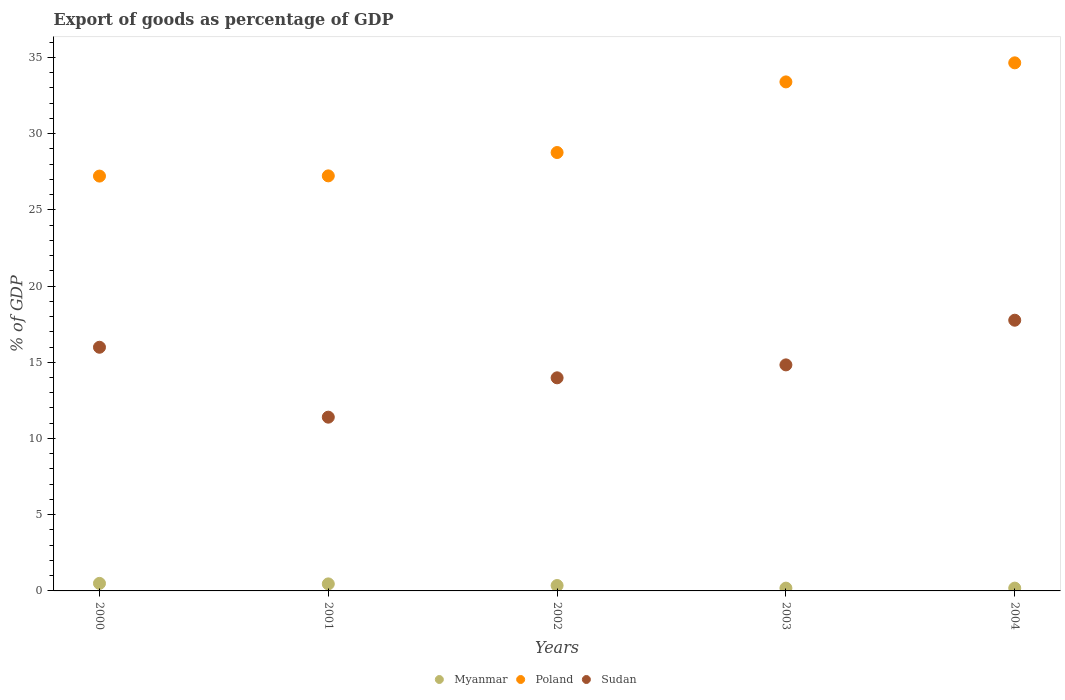How many different coloured dotlines are there?
Provide a succinct answer. 3. Is the number of dotlines equal to the number of legend labels?
Keep it short and to the point. Yes. What is the export of goods as percentage of GDP in Sudan in 2004?
Ensure brevity in your answer.  17.76. Across all years, what is the maximum export of goods as percentage of GDP in Sudan?
Give a very brief answer. 17.76. Across all years, what is the minimum export of goods as percentage of GDP in Myanmar?
Ensure brevity in your answer.  0.18. In which year was the export of goods as percentage of GDP in Sudan maximum?
Make the answer very short. 2004. What is the total export of goods as percentage of GDP in Poland in the graph?
Offer a terse response. 151.23. What is the difference between the export of goods as percentage of GDP in Poland in 2000 and that in 2004?
Offer a very short reply. -7.43. What is the difference between the export of goods as percentage of GDP in Sudan in 2004 and the export of goods as percentage of GDP in Poland in 2000?
Provide a short and direct response. -9.45. What is the average export of goods as percentage of GDP in Myanmar per year?
Keep it short and to the point. 0.34. In the year 2003, what is the difference between the export of goods as percentage of GDP in Sudan and export of goods as percentage of GDP in Myanmar?
Your answer should be compact. 14.64. What is the ratio of the export of goods as percentage of GDP in Poland in 2001 to that in 2004?
Ensure brevity in your answer.  0.79. Is the difference between the export of goods as percentage of GDP in Sudan in 2003 and 2004 greater than the difference between the export of goods as percentage of GDP in Myanmar in 2003 and 2004?
Provide a short and direct response. No. What is the difference between the highest and the second highest export of goods as percentage of GDP in Poland?
Your answer should be very brief. 1.25. What is the difference between the highest and the lowest export of goods as percentage of GDP in Poland?
Offer a very short reply. 7.43. Does the export of goods as percentage of GDP in Poland monotonically increase over the years?
Keep it short and to the point. Yes. Is the export of goods as percentage of GDP in Poland strictly less than the export of goods as percentage of GDP in Sudan over the years?
Keep it short and to the point. No. How many dotlines are there?
Keep it short and to the point. 3. How many years are there in the graph?
Provide a short and direct response. 5. Are the values on the major ticks of Y-axis written in scientific E-notation?
Ensure brevity in your answer.  No. Where does the legend appear in the graph?
Offer a very short reply. Bottom center. How are the legend labels stacked?
Your answer should be compact. Horizontal. What is the title of the graph?
Give a very brief answer. Export of goods as percentage of GDP. Does "Latin America(all income levels)" appear as one of the legend labels in the graph?
Give a very brief answer. No. What is the label or title of the Y-axis?
Keep it short and to the point. % of GDP. What is the % of GDP of Myanmar in 2000?
Make the answer very short. 0.49. What is the % of GDP in Poland in 2000?
Keep it short and to the point. 27.21. What is the % of GDP of Sudan in 2000?
Provide a short and direct response. 15.98. What is the % of GDP of Myanmar in 2001?
Your response must be concise. 0.46. What is the % of GDP of Poland in 2001?
Ensure brevity in your answer.  27.23. What is the % of GDP in Sudan in 2001?
Offer a terse response. 11.4. What is the % of GDP in Myanmar in 2002?
Offer a very short reply. 0.35. What is the % of GDP of Poland in 2002?
Give a very brief answer. 28.76. What is the % of GDP of Sudan in 2002?
Your response must be concise. 13.98. What is the % of GDP in Myanmar in 2003?
Provide a succinct answer. 0.18. What is the % of GDP in Poland in 2003?
Your answer should be compact. 33.39. What is the % of GDP in Sudan in 2003?
Provide a succinct answer. 14.83. What is the % of GDP in Myanmar in 2004?
Your answer should be compact. 0.18. What is the % of GDP in Poland in 2004?
Ensure brevity in your answer.  34.64. What is the % of GDP of Sudan in 2004?
Make the answer very short. 17.76. Across all years, what is the maximum % of GDP in Myanmar?
Provide a succinct answer. 0.49. Across all years, what is the maximum % of GDP in Poland?
Give a very brief answer. 34.64. Across all years, what is the maximum % of GDP of Sudan?
Make the answer very short. 17.76. Across all years, what is the minimum % of GDP of Myanmar?
Provide a short and direct response. 0.18. Across all years, what is the minimum % of GDP in Poland?
Offer a very short reply. 27.21. Across all years, what is the minimum % of GDP of Sudan?
Your answer should be very brief. 11.4. What is the total % of GDP of Myanmar in the graph?
Your answer should be compact. 1.68. What is the total % of GDP of Poland in the graph?
Offer a very short reply. 151.23. What is the total % of GDP of Sudan in the graph?
Your answer should be very brief. 73.95. What is the difference between the % of GDP in Myanmar in 2000 and that in 2001?
Make the answer very short. 0.03. What is the difference between the % of GDP in Poland in 2000 and that in 2001?
Offer a very short reply. -0.01. What is the difference between the % of GDP in Sudan in 2000 and that in 2001?
Make the answer very short. 4.59. What is the difference between the % of GDP in Myanmar in 2000 and that in 2002?
Make the answer very short. 0.14. What is the difference between the % of GDP in Poland in 2000 and that in 2002?
Provide a succinct answer. -1.55. What is the difference between the % of GDP of Sudan in 2000 and that in 2002?
Keep it short and to the point. 2.01. What is the difference between the % of GDP in Myanmar in 2000 and that in 2003?
Your response must be concise. 0.31. What is the difference between the % of GDP of Poland in 2000 and that in 2003?
Give a very brief answer. -6.18. What is the difference between the % of GDP in Sudan in 2000 and that in 2003?
Offer a terse response. 1.16. What is the difference between the % of GDP in Myanmar in 2000 and that in 2004?
Your answer should be very brief. 0.31. What is the difference between the % of GDP in Poland in 2000 and that in 2004?
Provide a succinct answer. -7.43. What is the difference between the % of GDP in Sudan in 2000 and that in 2004?
Keep it short and to the point. -1.77. What is the difference between the % of GDP of Myanmar in 2001 and that in 2002?
Your answer should be compact. 0.11. What is the difference between the % of GDP of Poland in 2001 and that in 2002?
Your answer should be compact. -1.53. What is the difference between the % of GDP of Sudan in 2001 and that in 2002?
Ensure brevity in your answer.  -2.58. What is the difference between the % of GDP of Myanmar in 2001 and that in 2003?
Provide a short and direct response. 0.28. What is the difference between the % of GDP of Poland in 2001 and that in 2003?
Ensure brevity in your answer.  -6.16. What is the difference between the % of GDP in Sudan in 2001 and that in 2003?
Keep it short and to the point. -3.43. What is the difference between the % of GDP in Myanmar in 2001 and that in 2004?
Ensure brevity in your answer.  0.28. What is the difference between the % of GDP in Poland in 2001 and that in 2004?
Provide a succinct answer. -7.41. What is the difference between the % of GDP of Sudan in 2001 and that in 2004?
Make the answer very short. -6.36. What is the difference between the % of GDP of Myanmar in 2002 and that in 2003?
Make the answer very short. 0.17. What is the difference between the % of GDP of Poland in 2002 and that in 2003?
Ensure brevity in your answer.  -4.63. What is the difference between the % of GDP in Sudan in 2002 and that in 2003?
Offer a terse response. -0.85. What is the difference between the % of GDP of Myanmar in 2002 and that in 2004?
Your response must be concise. 0.17. What is the difference between the % of GDP in Poland in 2002 and that in 2004?
Ensure brevity in your answer.  -5.88. What is the difference between the % of GDP in Sudan in 2002 and that in 2004?
Your answer should be very brief. -3.78. What is the difference between the % of GDP of Myanmar in 2003 and that in 2004?
Your response must be concise. -0. What is the difference between the % of GDP of Poland in 2003 and that in 2004?
Offer a very short reply. -1.25. What is the difference between the % of GDP of Sudan in 2003 and that in 2004?
Offer a very short reply. -2.93. What is the difference between the % of GDP in Myanmar in 2000 and the % of GDP in Poland in 2001?
Your answer should be very brief. -26.73. What is the difference between the % of GDP of Myanmar in 2000 and the % of GDP of Sudan in 2001?
Your answer should be very brief. -10.9. What is the difference between the % of GDP of Poland in 2000 and the % of GDP of Sudan in 2001?
Offer a terse response. 15.82. What is the difference between the % of GDP of Myanmar in 2000 and the % of GDP of Poland in 2002?
Give a very brief answer. -28.26. What is the difference between the % of GDP of Myanmar in 2000 and the % of GDP of Sudan in 2002?
Provide a succinct answer. -13.48. What is the difference between the % of GDP in Poland in 2000 and the % of GDP in Sudan in 2002?
Offer a terse response. 13.23. What is the difference between the % of GDP of Myanmar in 2000 and the % of GDP of Poland in 2003?
Offer a terse response. -32.9. What is the difference between the % of GDP in Myanmar in 2000 and the % of GDP in Sudan in 2003?
Ensure brevity in your answer.  -14.33. What is the difference between the % of GDP of Poland in 2000 and the % of GDP of Sudan in 2003?
Your response must be concise. 12.39. What is the difference between the % of GDP of Myanmar in 2000 and the % of GDP of Poland in 2004?
Provide a succinct answer. -34.15. What is the difference between the % of GDP in Myanmar in 2000 and the % of GDP in Sudan in 2004?
Your answer should be compact. -17.26. What is the difference between the % of GDP of Poland in 2000 and the % of GDP of Sudan in 2004?
Your answer should be very brief. 9.46. What is the difference between the % of GDP of Myanmar in 2001 and the % of GDP of Poland in 2002?
Make the answer very short. -28.3. What is the difference between the % of GDP in Myanmar in 2001 and the % of GDP in Sudan in 2002?
Ensure brevity in your answer.  -13.52. What is the difference between the % of GDP of Poland in 2001 and the % of GDP of Sudan in 2002?
Offer a very short reply. 13.25. What is the difference between the % of GDP in Myanmar in 2001 and the % of GDP in Poland in 2003?
Give a very brief answer. -32.93. What is the difference between the % of GDP of Myanmar in 2001 and the % of GDP of Sudan in 2003?
Ensure brevity in your answer.  -14.37. What is the difference between the % of GDP in Poland in 2001 and the % of GDP in Sudan in 2003?
Provide a short and direct response. 12.4. What is the difference between the % of GDP in Myanmar in 2001 and the % of GDP in Poland in 2004?
Offer a very short reply. -34.18. What is the difference between the % of GDP of Myanmar in 2001 and the % of GDP of Sudan in 2004?
Ensure brevity in your answer.  -17.3. What is the difference between the % of GDP in Poland in 2001 and the % of GDP in Sudan in 2004?
Your answer should be compact. 9.47. What is the difference between the % of GDP of Myanmar in 2002 and the % of GDP of Poland in 2003?
Give a very brief answer. -33.04. What is the difference between the % of GDP in Myanmar in 2002 and the % of GDP in Sudan in 2003?
Provide a succinct answer. -14.47. What is the difference between the % of GDP of Poland in 2002 and the % of GDP of Sudan in 2003?
Provide a succinct answer. 13.93. What is the difference between the % of GDP of Myanmar in 2002 and the % of GDP of Poland in 2004?
Keep it short and to the point. -34.29. What is the difference between the % of GDP of Myanmar in 2002 and the % of GDP of Sudan in 2004?
Give a very brief answer. -17.4. What is the difference between the % of GDP in Poland in 2002 and the % of GDP in Sudan in 2004?
Your answer should be very brief. 11. What is the difference between the % of GDP in Myanmar in 2003 and the % of GDP in Poland in 2004?
Make the answer very short. -34.46. What is the difference between the % of GDP in Myanmar in 2003 and the % of GDP in Sudan in 2004?
Provide a short and direct response. -17.57. What is the difference between the % of GDP in Poland in 2003 and the % of GDP in Sudan in 2004?
Make the answer very short. 15.63. What is the average % of GDP of Myanmar per year?
Keep it short and to the point. 0.34. What is the average % of GDP of Poland per year?
Ensure brevity in your answer.  30.25. What is the average % of GDP of Sudan per year?
Make the answer very short. 14.79. In the year 2000, what is the difference between the % of GDP of Myanmar and % of GDP of Poland?
Your response must be concise. -26.72. In the year 2000, what is the difference between the % of GDP in Myanmar and % of GDP in Sudan?
Offer a very short reply. -15.49. In the year 2000, what is the difference between the % of GDP in Poland and % of GDP in Sudan?
Provide a succinct answer. 11.23. In the year 2001, what is the difference between the % of GDP of Myanmar and % of GDP of Poland?
Your answer should be compact. -26.77. In the year 2001, what is the difference between the % of GDP in Myanmar and % of GDP in Sudan?
Provide a succinct answer. -10.94. In the year 2001, what is the difference between the % of GDP in Poland and % of GDP in Sudan?
Keep it short and to the point. 15.83. In the year 2002, what is the difference between the % of GDP in Myanmar and % of GDP in Poland?
Provide a succinct answer. -28.4. In the year 2002, what is the difference between the % of GDP of Myanmar and % of GDP of Sudan?
Offer a terse response. -13.62. In the year 2002, what is the difference between the % of GDP in Poland and % of GDP in Sudan?
Your answer should be compact. 14.78. In the year 2003, what is the difference between the % of GDP in Myanmar and % of GDP in Poland?
Keep it short and to the point. -33.21. In the year 2003, what is the difference between the % of GDP in Myanmar and % of GDP in Sudan?
Keep it short and to the point. -14.64. In the year 2003, what is the difference between the % of GDP of Poland and % of GDP of Sudan?
Offer a terse response. 18.56. In the year 2004, what is the difference between the % of GDP in Myanmar and % of GDP in Poland?
Keep it short and to the point. -34.46. In the year 2004, what is the difference between the % of GDP of Myanmar and % of GDP of Sudan?
Give a very brief answer. -17.57. In the year 2004, what is the difference between the % of GDP of Poland and % of GDP of Sudan?
Offer a terse response. 16.88. What is the ratio of the % of GDP in Myanmar in 2000 to that in 2001?
Your response must be concise. 1.07. What is the ratio of the % of GDP in Poland in 2000 to that in 2001?
Make the answer very short. 1. What is the ratio of the % of GDP of Sudan in 2000 to that in 2001?
Ensure brevity in your answer.  1.4. What is the ratio of the % of GDP of Myanmar in 2000 to that in 2002?
Offer a very short reply. 1.39. What is the ratio of the % of GDP of Poland in 2000 to that in 2002?
Give a very brief answer. 0.95. What is the ratio of the % of GDP in Sudan in 2000 to that in 2002?
Ensure brevity in your answer.  1.14. What is the ratio of the % of GDP of Myanmar in 2000 to that in 2003?
Provide a short and direct response. 2.7. What is the ratio of the % of GDP in Poland in 2000 to that in 2003?
Keep it short and to the point. 0.81. What is the ratio of the % of GDP of Sudan in 2000 to that in 2003?
Your answer should be compact. 1.08. What is the ratio of the % of GDP in Myanmar in 2000 to that in 2004?
Offer a terse response. 2.69. What is the ratio of the % of GDP in Poland in 2000 to that in 2004?
Give a very brief answer. 0.79. What is the ratio of the % of GDP in Sudan in 2000 to that in 2004?
Keep it short and to the point. 0.9. What is the ratio of the % of GDP of Myanmar in 2001 to that in 2002?
Your response must be concise. 1.3. What is the ratio of the % of GDP of Poland in 2001 to that in 2002?
Offer a very short reply. 0.95. What is the ratio of the % of GDP in Sudan in 2001 to that in 2002?
Your answer should be compact. 0.82. What is the ratio of the % of GDP in Myanmar in 2001 to that in 2003?
Give a very brief answer. 2.52. What is the ratio of the % of GDP in Poland in 2001 to that in 2003?
Give a very brief answer. 0.82. What is the ratio of the % of GDP of Sudan in 2001 to that in 2003?
Offer a terse response. 0.77. What is the ratio of the % of GDP of Myanmar in 2001 to that in 2004?
Ensure brevity in your answer.  2.51. What is the ratio of the % of GDP of Poland in 2001 to that in 2004?
Provide a succinct answer. 0.79. What is the ratio of the % of GDP in Sudan in 2001 to that in 2004?
Your answer should be very brief. 0.64. What is the ratio of the % of GDP in Myanmar in 2002 to that in 2003?
Provide a short and direct response. 1.94. What is the ratio of the % of GDP of Poland in 2002 to that in 2003?
Your answer should be very brief. 0.86. What is the ratio of the % of GDP of Sudan in 2002 to that in 2003?
Your response must be concise. 0.94. What is the ratio of the % of GDP of Myanmar in 2002 to that in 2004?
Offer a terse response. 1.93. What is the ratio of the % of GDP in Poland in 2002 to that in 2004?
Provide a succinct answer. 0.83. What is the ratio of the % of GDP in Sudan in 2002 to that in 2004?
Offer a very short reply. 0.79. What is the ratio of the % of GDP of Poland in 2003 to that in 2004?
Provide a short and direct response. 0.96. What is the ratio of the % of GDP in Sudan in 2003 to that in 2004?
Your answer should be compact. 0.83. What is the difference between the highest and the second highest % of GDP in Myanmar?
Provide a succinct answer. 0.03. What is the difference between the highest and the second highest % of GDP in Poland?
Your answer should be compact. 1.25. What is the difference between the highest and the second highest % of GDP in Sudan?
Provide a succinct answer. 1.77. What is the difference between the highest and the lowest % of GDP in Myanmar?
Provide a short and direct response. 0.31. What is the difference between the highest and the lowest % of GDP in Poland?
Your answer should be compact. 7.43. What is the difference between the highest and the lowest % of GDP in Sudan?
Offer a terse response. 6.36. 